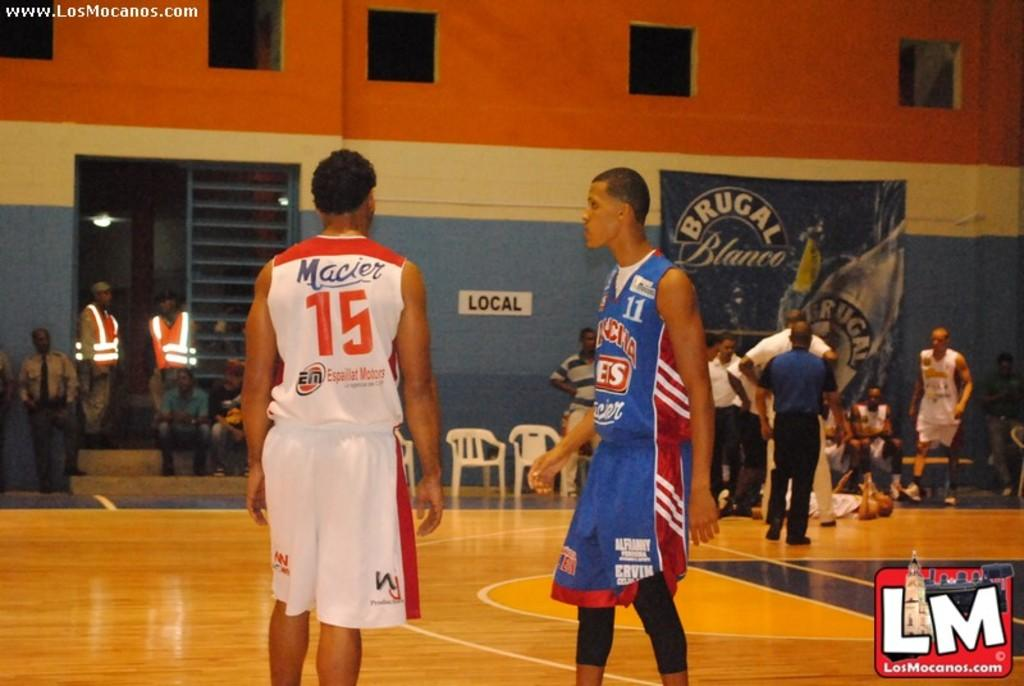Provide a one-sentence caption for the provided image. Basket ball players on opposing teams wearing numbers 15 and 11 stand in the middle of the court. 